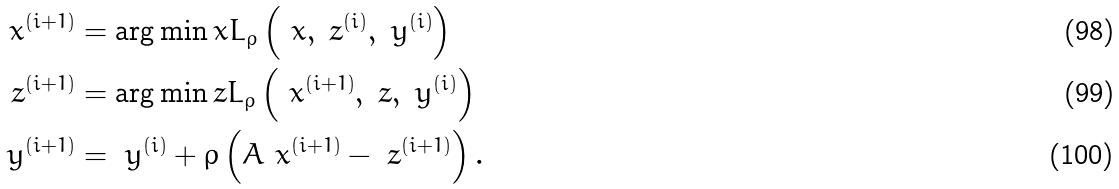<formula> <loc_0><loc_0><loc_500><loc_500>\ x ^ { ( i + 1 ) } & = \arg \min _ { \ } x L _ { \rho } \left ( \ x , \ z ^ { ( i ) } , \ y ^ { ( i ) } \right ) \\ \ z ^ { ( i + 1 ) } & = \arg \min _ { \ } z L _ { \rho } \left ( \ x ^ { ( i + 1 ) } , \ z , \ y ^ { ( i ) } \right ) \\ \ y ^ { ( i + 1 ) } & = \ y ^ { ( i ) } + \rho \left ( A \ x ^ { ( i + 1 ) } - \ z ^ { ( i + 1 ) } \right ) .</formula> 